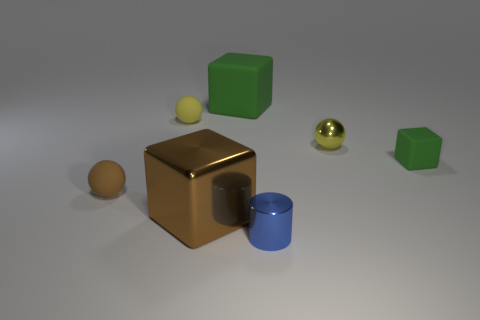How many other spheres have the same color as the metal sphere?
Provide a succinct answer. 1. How big is the cube that is in front of the small brown matte sphere?
Offer a very short reply. Large. Is the color of the block to the right of the big rubber thing the same as the large rubber thing?
Provide a short and direct response. Yes. The tiny matte thing that is both left of the tiny green block and in front of the metallic ball has what shape?
Provide a short and direct response. Sphere. There is a metallic block that is right of the brown rubber ball that is on the left side of the yellow rubber ball; what is its size?
Provide a succinct answer. Large. How many tiny green matte objects have the same shape as the yellow metallic thing?
Provide a succinct answer. 0. Does the tiny cube have the same color as the big rubber block?
Your answer should be compact. Yes. Is there anything else that is the same shape as the tiny blue metal thing?
Provide a short and direct response. No. Are there any small matte things of the same color as the large rubber block?
Your answer should be very brief. Yes. Does the brown thing right of the brown matte thing have the same material as the yellow sphere left of the large green matte thing?
Keep it short and to the point. No. 